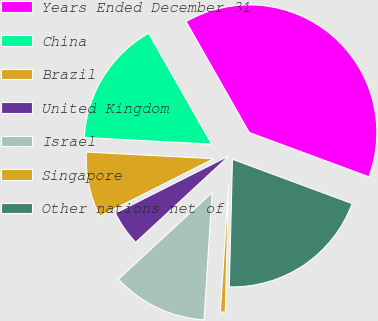Convert chart. <chart><loc_0><loc_0><loc_500><loc_500><pie_chart><fcel>Years Ended December 31<fcel>China<fcel>Brazil<fcel>United Kingdom<fcel>Israel<fcel>Singapore<fcel>Other nations net of<nl><fcel>38.88%<fcel>15.93%<fcel>8.27%<fcel>4.45%<fcel>12.1%<fcel>0.62%<fcel>19.75%<nl></chart> 